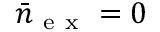<formula> <loc_0><loc_0><loc_500><loc_500>\bar { n } _ { e x } = 0</formula> 